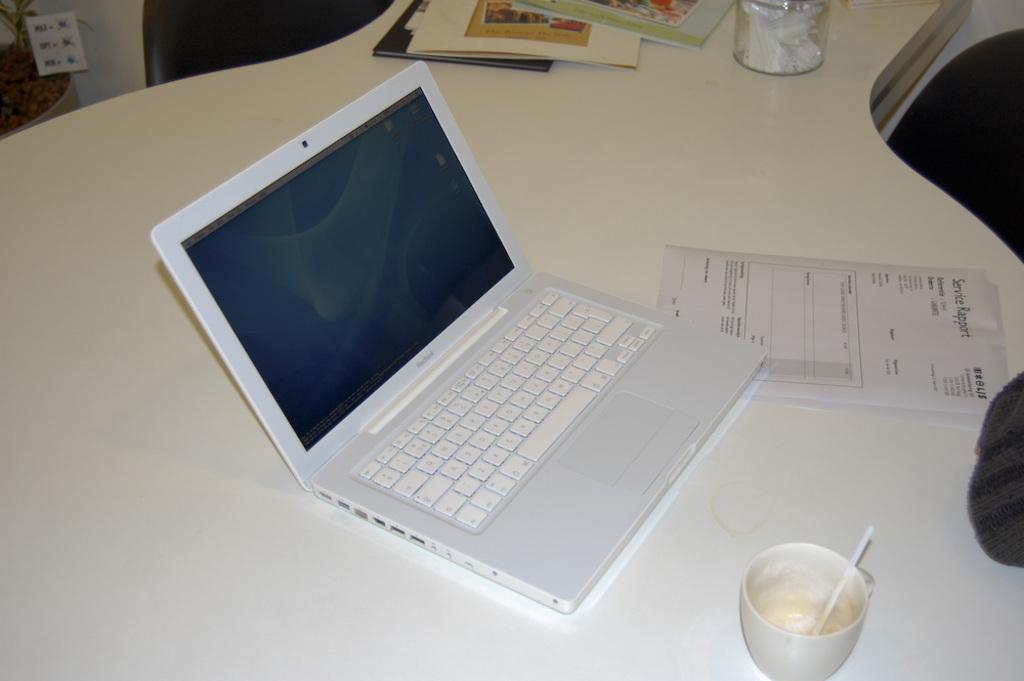In one or two sentences, can you explain what this image depicts? This is a picture, In the picture there is a table on the table there is a laptop, paper and the cup and the books. 